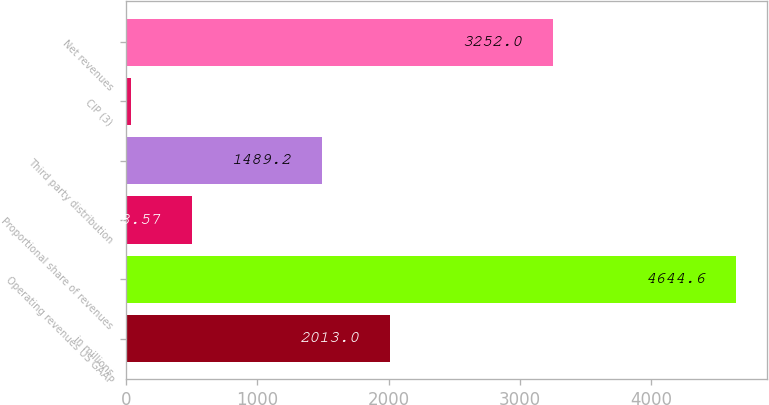<chart> <loc_0><loc_0><loc_500><loc_500><bar_chart><fcel>in millions<fcel>Operating revenues US GAAP<fcel>Proportional share of revenues<fcel>Third party distribution<fcel>CIP (3)<fcel>Net revenues<nl><fcel>2013<fcel>4644.6<fcel>498.57<fcel>1489.2<fcel>37.9<fcel>3252<nl></chart> 